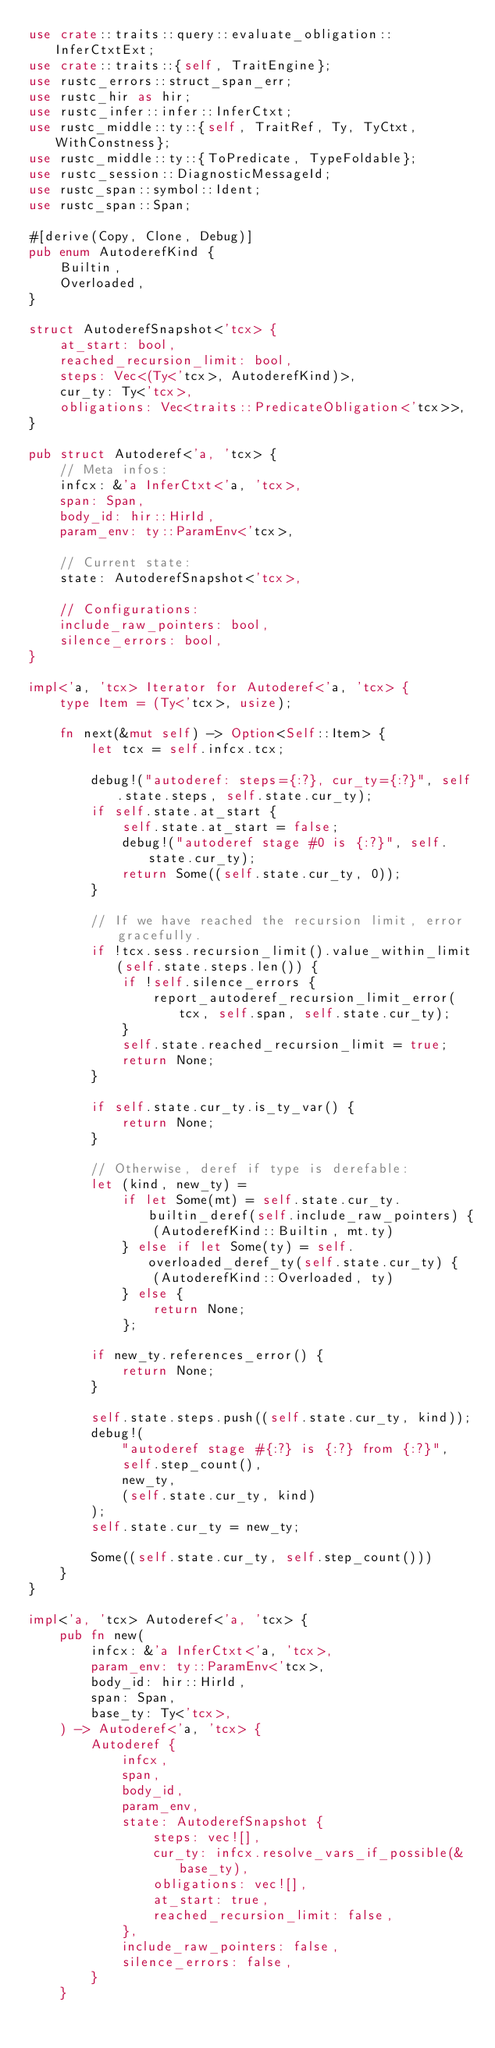Convert code to text. <code><loc_0><loc_0><loc_500><loc_500><_Rust_>use crate::traits::query::evaluate_obligation::InferCtxtExt;
use crate::traits::{self, TraitEngine};
use rustc_errors::struct_span_err;
use rustc_hir as hir;
use rustc_infer::infer::InferCtxt;
use rustc_middle::ty::{self, TraitRef, Ty, TyCtxt, WithConstness};
use rustc_middle::ty::{ToPredicate, TypeFoldable};
use rustc_session::DiagnosticMessageId;
use rustc_span::symbol::Ident;
use rustc_span::Span;

#[derive(Copy, Clone, Debug)]
pub enum AutoderefKind {
    Builtin,
    Overloaded,
}

struct AutoderefSnapshot<'tcx> {
    at_start: bool,
    reached_recursion_limit: bool,
    steps: Vec<(Ty<'tcx>, AutoderefKind)>,
    cur_ty: Ty<'tcx>,
    obligations: Vec<traits::PredicateObligation<'tcx>>,
}

pub struct Autoderef<'a, 'tcx> {
    // Meta infos:
    infcx: &'a InferCtxt<'a, 'tcx>,
    span: Span,
    body_id: hir::HirId,
    param_env: ty::ParamEnv<'tcx>,

    // Current state:
    state: AutoderefSnapshot<'tcx>,

    // Configurations:
    include_raw_pointers: bool,
    silence_errors: bool,
}

impl<'a, 'tcx> Iterator for Autoderef<'a, 'tcx> {
    type Item = (Ty<'tcx>, usize);

    fn next(&mut self) -> Option<Self::Item> {
        let tcx = self.infcx.tcx;

        debug!("autoderef: steps={:?}, cur_ty={:?}", self.state.steps, self.state.cur_ty);
        if self.state.at_start {
            self.state.at_start = false;
            debug!("autoderef stage #0 is {:?}", self.state.cur_ty);
            return Some((self.state.cur_ty, 0));
        }

        // If we have reached the recursion limit, error gracefully.
        if !tcx.sess.recursion_limit().value_within_limit(self.state.steps.len()) {
            if !self.silence_errors {
                report_autoderef_recursion_limit_error(tcx, self.span, self.state.cur_ty);
            }
            self.state.reached_recursion_limit = true;
            return None;
        }

        if self.state.cur_ty.is_ty_var() {
            return None;
        }

        // Otherwise, deref if type is derefable:
        let (kind, new_ty) =
            if let Some(mt) = self.state.cur_ty.builtin_deref(self.include_raw_pointers) {
                (AutoderefKind::Builtin, mt.ty)
            } else if let Some(ty) = self.overloaded_deref_ty(self.state.cur_ty) {
                (AutoderefKind::Overloaded, ty)
            } else {
                return None;
            };

        if new_ty.references_error() {
            return None;
        }

        self.state.steps.push((self.state.cur_ty, kind));
        debug!(
            "autoderef stage #{:?} is {:?} from {:?}",
            self.step_count(),
            new_ty,
            (self.state.cur_ty, kind)
        );
        self.state.cur_ty = new_ty;

        Some((self.state.cur_ty, self.step_count()))
    }
}

impl<'a, 'tcx> Autoderef<'a, 'tcx> {
    pub fn new(
        infcx: &'a InferCtxt<'a, 'tcx>,
        param_env: ty::ParamEnv<'tcx>,
        body_id: hir::HirId,
        span: Span,
        base_ty: Ty<'tcx>,
    ) -> Autoderef<'a, 'tcx> {
        Autoderef {
            infcx,
            span,
            body_id,
            param_env,
            state: AutoderefSnapshot {
                steps: vec![],
                cur_ty: infcx.resolve_vars_if_possible(&base_ty),
                obligations: vec![],
                at_start: true,
                reached_recursion_limit: false,
            },
            include_raw_pointers: false,
            silence_errors: false,
        }
    }
</code> 